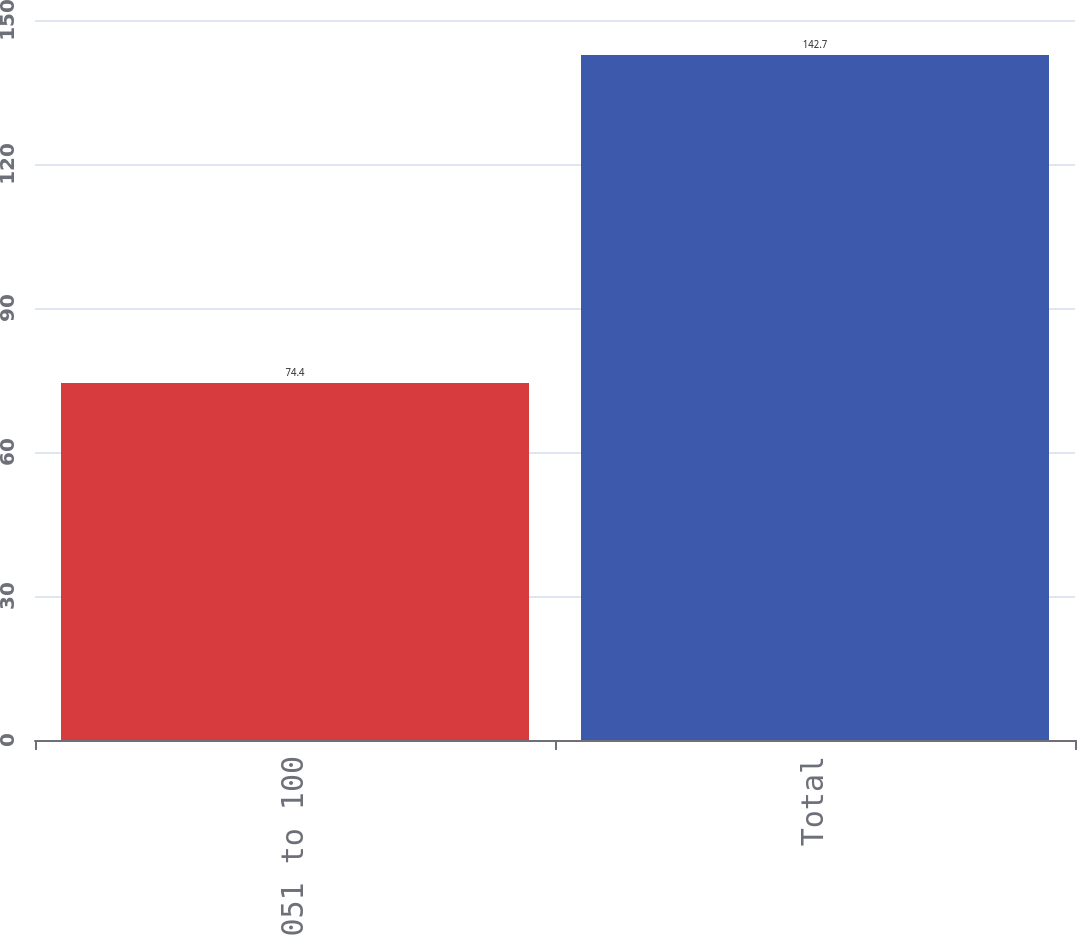Convert chart. <chart><loc_0><loc_0><loc_500><loc_500><bar_chart><fcel>051 to 100<fcel>Total<nl><fcel>74.4<fcel>142.7<nl></chart> 